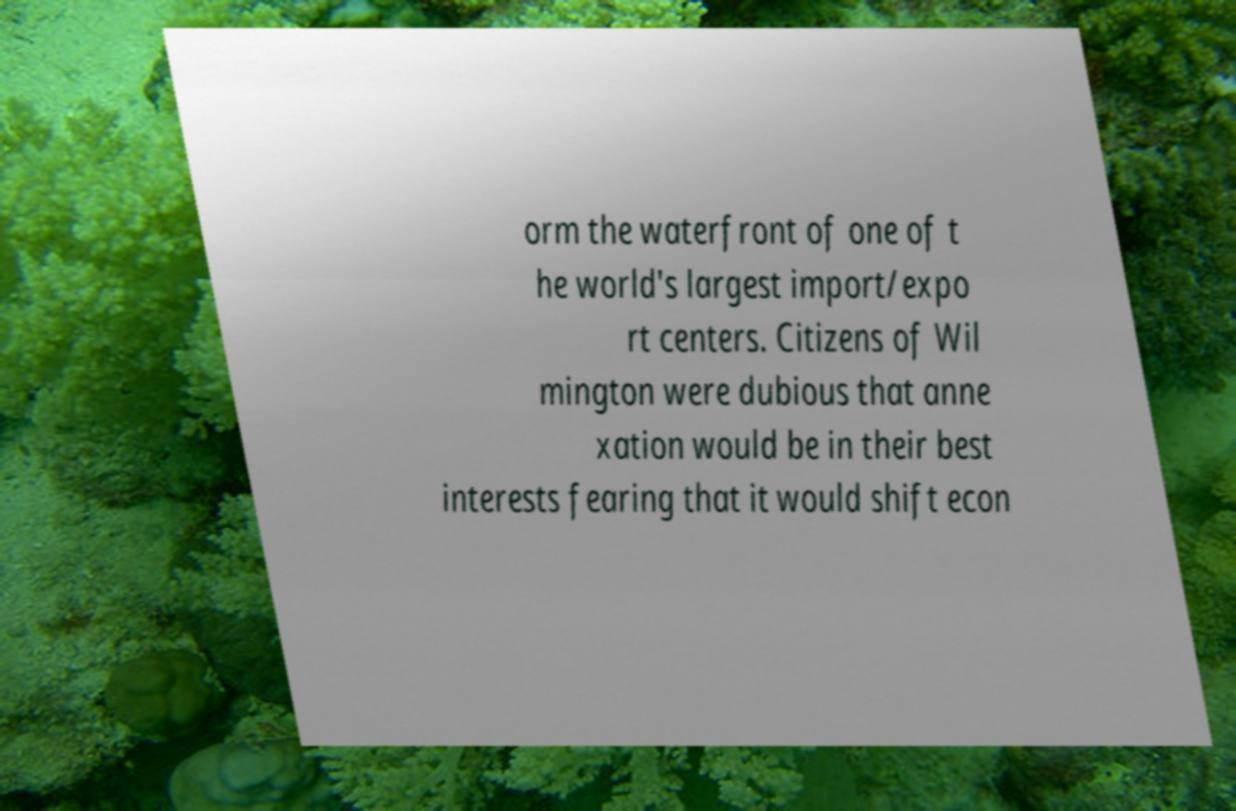There's text embedded in this image that I need extracted. Can you transcribe it verbatim? orm the waterfront of one of t he world's largest import/expo rt centers. Citizens of Wil mington were dubious that anne xation would be in their best interests fearing that it would shift econ 